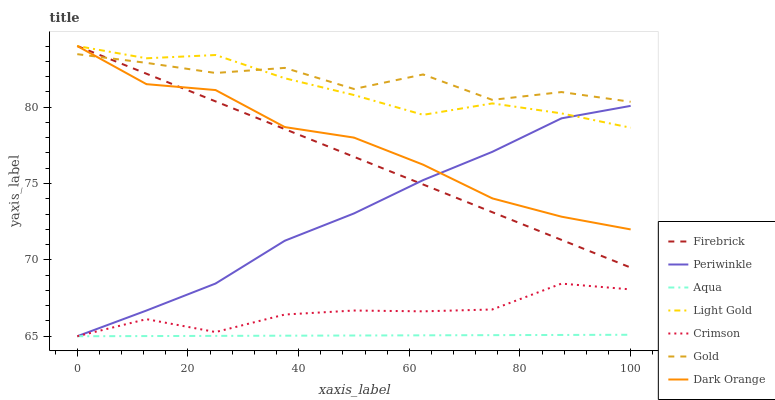Does Aqua have the minimum area under the curve?
Answer yes or no. Yes. Does Gold have the maximum area under the curve?
Answer yes or no. Yes. Does Firebrick have the minimum area under the curve?
Answer yes or no. No. Does Firebrick have the maximum area under the curve?
Answer yes or no. No. Is Aqua the smoothest?
Answer yes or no. Yes. Is Gold the roughest?
Answer yes or no. Yes. Is Firebrick the smoothest?
Answer yes or no. No. Is Firebrick the roughest?
Answer yes or no. No. Does Firebrick have the lowest value?
Answer yes or no. No. Does Light Gold have the highest value?
Answer yes or no. Yes. Does Gold have the highest value?
Answer yes or no. No. Is Aqua less than Dark Orange?
Answer yes or no. Yes. Is Gold greater than Periwinkle?
Answer yes or no. Yes. Does Firebrick intersect Gold?
Answer yes or no. Yes. Is Firebrick less than Gold?
Answer yes or no. No. Is Firebrick greater than Gold?
Answer yes or no. No. Does Aqua intersect Dark Orange?
Answer yes or no. No. 